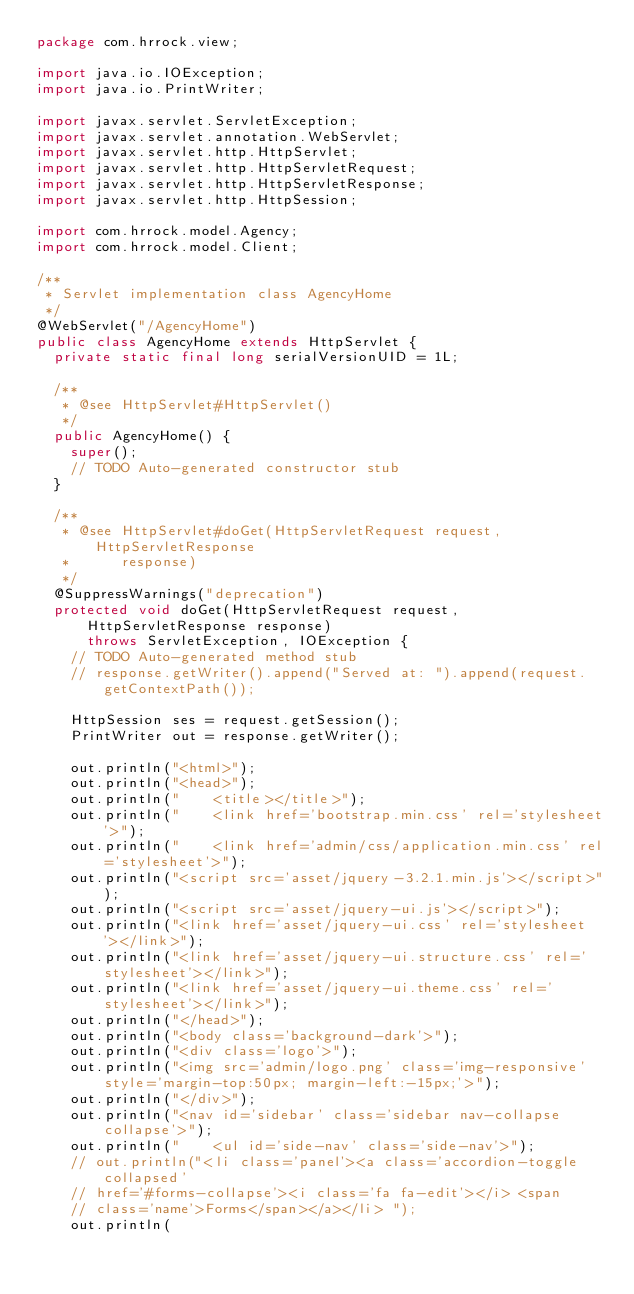Convert code to text. <code><loc_0><loc_0><loc_500><loc_500><_Java_>package com.hrrock.view;

import java.io.IOException;
import java.io.PrintWriter;

import javax.servlet.ServletException;
import javax.servlet.annotation.WebServlet;
import javax.servlet.http.HttpServlet;
import javax.servlet.http.HttpServletRequest;
import javax.servlet.http.HttpServletResponse;
import javax.servlet.http.HttpSession;

import com.hrrock.model.Agency;
import com.hrrock.model.Client;

/**
 * Servlet implementation class AgencyHome
 */
@WebServlet("/AgencyHome")
public class AgencyHome extends HttpServlet {
	private static final long serialVersionUID = 1L;

	/**
	 * @see HttpServlet#HttpServlet()
	 */
	public AgencyHome() {
		super();
		// TODO Auto-generated constructor stub
	}

	/**
	 * @see HttpServlet#doGet(HttpServletRequest request, HttpServletResponse
	 *      response)
	 */
	@SuppressWarnings("deprecation")
	protected void doGet(HttpServletRequest request, HttpServletResponse response)
			throws ServletException, IOException {
		// TODO Auto-generated method stub
		// response.getWriter().append("Served at: ").append(request.getContextPath());

		HttpSession ses = request.getSession();
		PrintWriter out = response.getWriter();

		out.println("<html>");
		out.println("<head>");
		out.println("    <title></title>");
		out.println("    <link href='bootstrap.min.css' rel='stylesheet'>");
		out.println("    <link href='admin/css/application.min.css' rel='stylesheet'>");
		out.println("<script src='asset/jquery-3.2.1.min.js'></script>");
		out.println("<script src='asset/jquery-ui.js'></script>");
		out.println("<link href='asset/jquery-ui.css' rel='stylesheet'></link>");
		out.println("<link href='asset/jquery-ui.structure.css' rel='stylesheet'></link>");
		out.println("<link href='asset/jquery-ui.theme.css' rel='stylesheet'></link>");
		out.println("</head>");
		out.println("<body class='background-dark'>");
		out.println("<div class='logo'>");
		out.println("<img src='admin/logo.png' class='img-responsive' style='margin-top:50px; margin-left:-15px;'>");
		out.println("</div>");
		out.println("<nav id='sidebar' class='sidebar nav-collapse collapse'>");
		out.println("    <ul id='side-nav' class='side-nav'>");
		// out.println("<li class='panel'><a class='accordion-toggle collapsed'
		// href='#forms-collapse'><i class='fa fa-edit'></i> <span
		// class='name'>Forms</span></a></li> ");
		out.println(</code> 